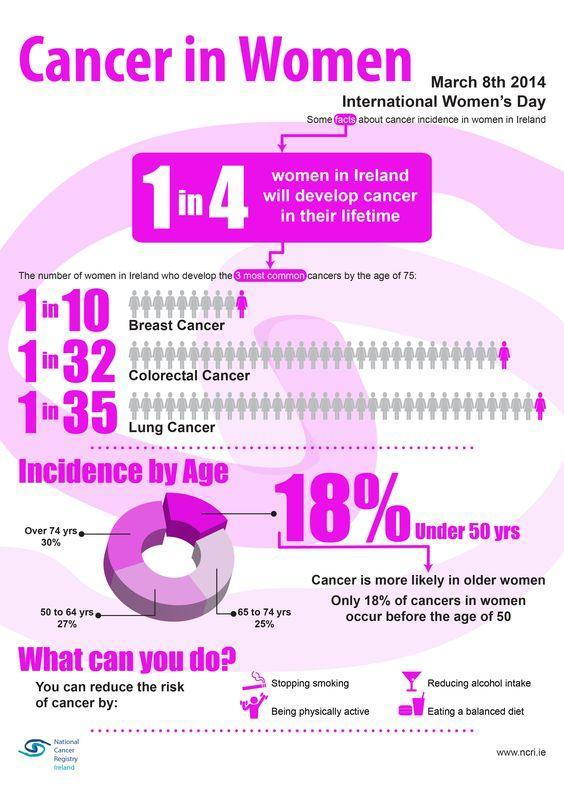What percentage of women over the age of 50 have incidence of cancer?
Answer the question with a short phrase. 27% What percentage of people aged under 50 to 64 years have incidences of cancer? 45% 